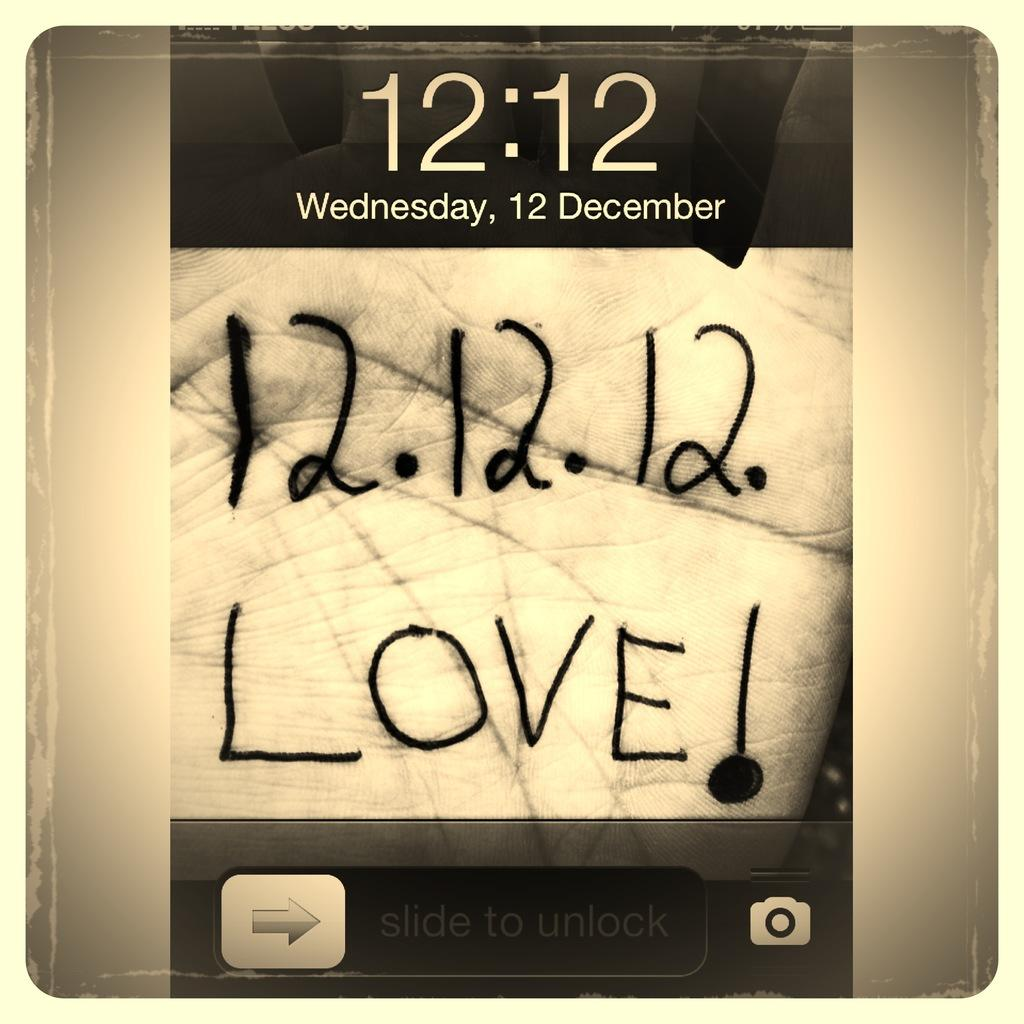<image>
Render a clear and concise summary of the photo. A phone screen displays the time of 12:12. 